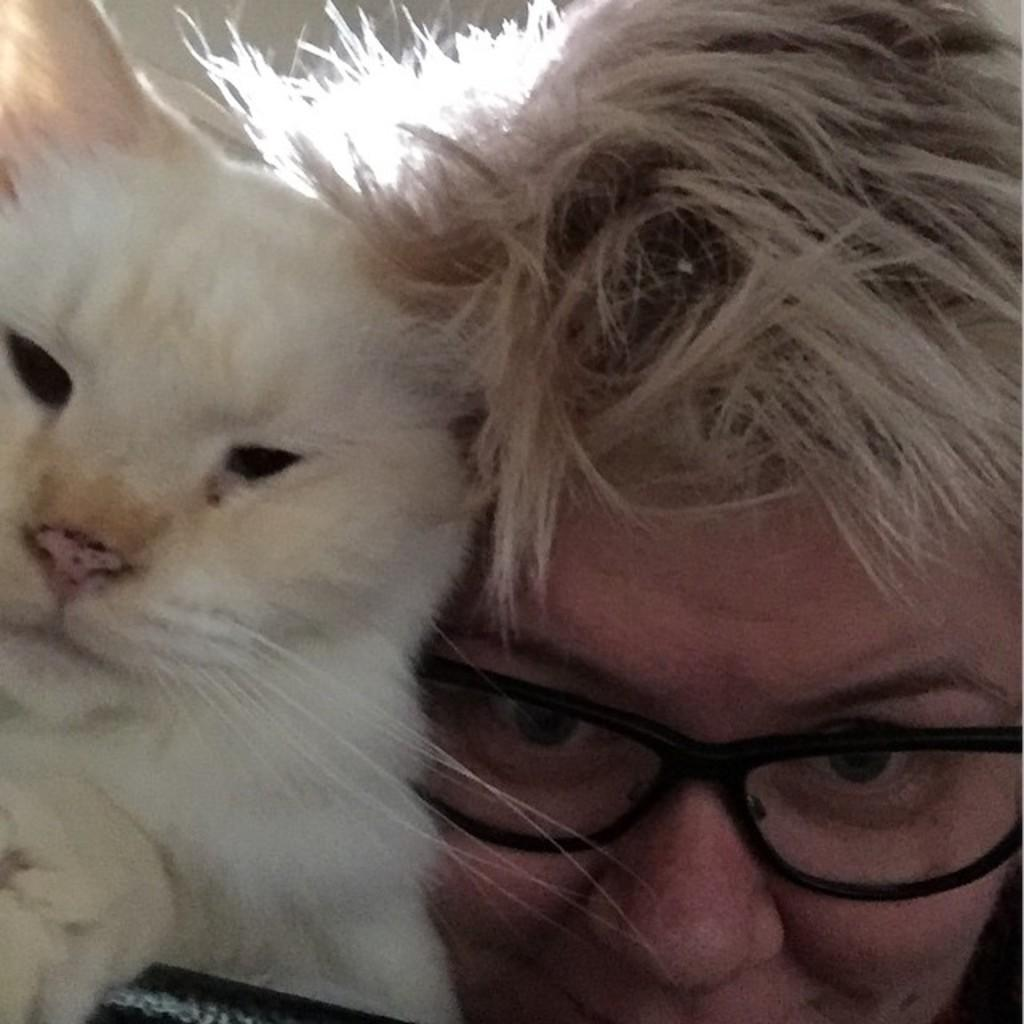What is present in the image? There is a person and a dog in the image. Can you describe the person's appearance? The person has white hair and is wearing spectacles. What color is the dog in the image? The dog is in white color. How many wheels can be seen on the person's nose in the image? There are no wheels present on the person's nose in the image. What type of end is visible on the dog's tail in the image? There is no mention of the dog's tail in the provided facts, so it cannot be determined from the image. 